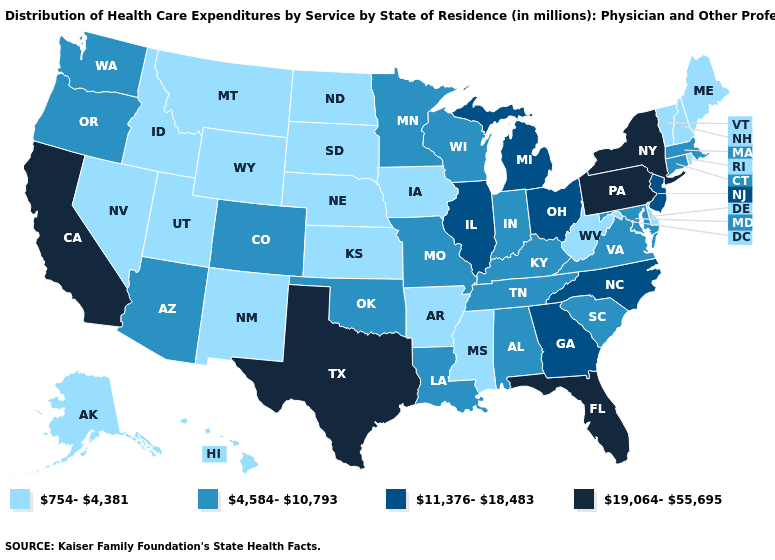What is the value of Vermont?
Concise answer only. 754-4,381. What is the highest value in the USA?
Write a very short answer. 19,064-55,695. What is the value of California?
Quick response, please. 19,064-55,695. Name the states that have a value in the range 19,064-55,695?
Write a very short answer. California, Florida, New York, Pennsylvania, Texas. Does Oregon have the same value as Texas?
Short answer required. No. Name the states that have a value in the range 19,064-55,695?
Be succinct. California, Florida, New York, Pennsylvania, Texas. Which states have the highest value in the USA?
Short answer required. California, Florida, New York, Pennsylvania, Texas. Which states have the lowest value in the South?
Keep it brief. Arkansas, Delaware, Mississippi, West Virginia. Name the states that have a value in the range 754-4,381?
Quick response, please. Alaska, Arkansas, Delaware, Hawaii, Idaho, Iowa, Kansas, Maine, Mississippi, Montana, Nebraska, Nevada, New Hampshire, New Mexico, North Dakota, Rhode Island, South Dakota, Utah, Vermont, West Virginia, Wyoming. How many symbols are there in the legend?
Concise answer only. 4. Does New Hampshire have the lowest value in the Northeast?
Quick response, please. Yes. What is the value of Iowa?
Give a very brief answer. 754-4,381. Which states have the lowest value in the Northeast?
Short answer required. Maine, New Hampshire, Rhode Island, Vermont. Which states have the highest value in the USA?
Concise answer only. California, Florida, New York, Pennsylvania, Texas. Does Connecticut have the lowest value in the Northeast?
Write a very short answer. No. 